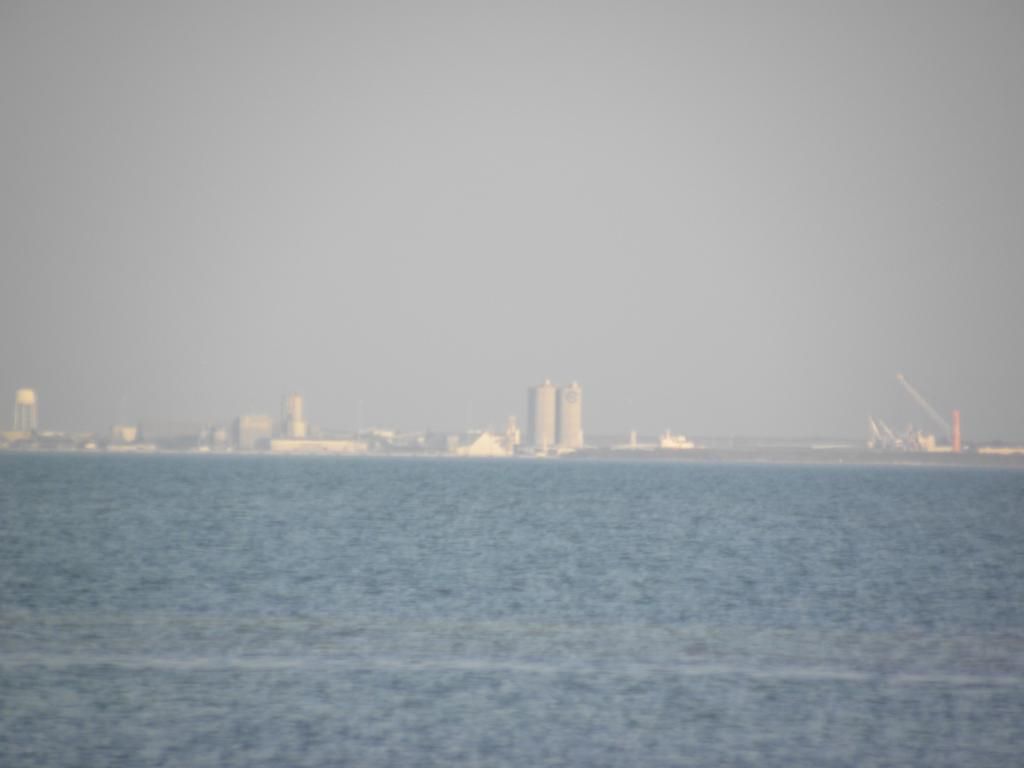Where was the image taken? The image was taken outdoors. What can be seen at the bottom of the image? There is a sea at the bottom of the image. What is visible at the top of the image? There is a sky at the top of the image. What type of structures can be seen in the background of the image? There are buildings in the background of the image. What advice is the sea giving to the buildings in the image? The sea does not give advice to the buildings in the image; it is a natural feature and does not have the ability to communicate or provide advice. 